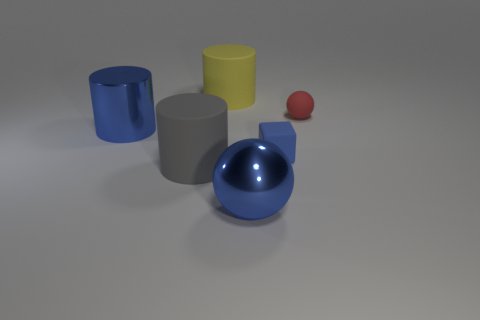How many things are either big rubber cylinders that are in front of the small red rubber sphere or big objects behind the large gray object?
Provide a succinct answer. 3. There is a large gray object; does it have the same shape as the big blue thing that is in front of the blue matte block?
Give a very brief answer. No. There is a big thing behind the large blue thing that is to the left of the rubber cylinder that is in front of the small rubber cube; what shape is it?
Ensure brevity in your answer.  Cylinder. What number of other objects are there of the same material as the big sphere?
Give a very brief answer. 1. How many objects are either big cylinders behind the large gray cylinder or big yellow rubber things?
Your response must be concise. 2. There is a large blue thing that is behind the small rubber object that is in front of the small matte sphere; what shape is it?
Your answer should be compact. Cylinder. There is a matte thing to the left of the large yellow thing; does it have the same shape as the red object?
Your answer should be compact. No. What is the color of the large rubber cylinder in front of the blue matte block?
Offer a terse response. Gray. What number of cylinders are either red rubber things or large gray rubber objects?
Offer a terse response. 1. What size is the blue metallic thing that is in front of the large matte cylinder that is in front of the blue cylinder?
Your response must be concise. Large. 